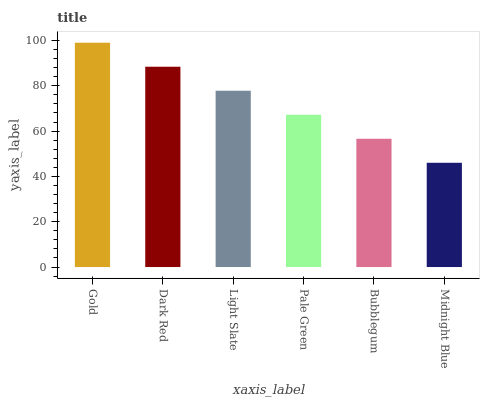Is Midnight Blue the minimum?
Answer yes or no. Yes. Is Gold the maximum?
Answer yes or no. Yes. Is Dark Red the minimum?
Answer yes or no. No. Is Dark Red the maximum?
Answer yes or no. No. Is Gold greater than Dark Red?
Answer yes or no. Yes. Is Dark Red less than Gold?
Answer yes or no. Yes. Is Dark Red greater than Gold?
Answer yes or no. No. Is Gold less than Dark Red?
Answer yes or no. No. Is Light Slate the high median?
Answer yes or no. Yes. Is Pale Green the low median?
Answer yes or no. Yes. Is Bubblegum the high median?
Answer yes or no. No. Is Bubblegum the low median?
Answer yes or no. No. 